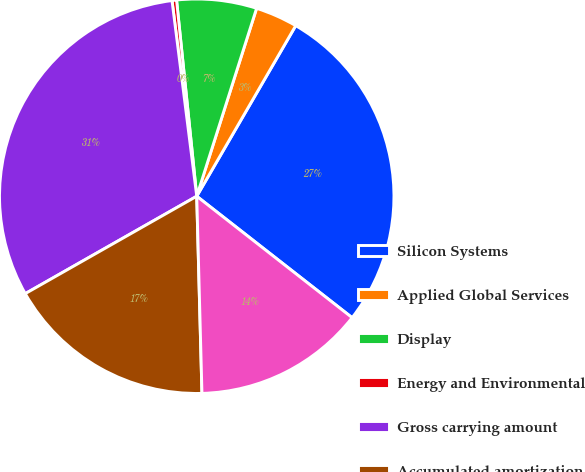<chart> <loc_0><loc_0><loc_500><loc_500><pie_chart><fcel>Silicon Systems<fcel>Applied Global Services<fcel>Display<fcel>Energy and Environmental<fcel>Gross carrying amount<fcel>Accumulated amortization<fcel>Carrying amount<nl><fcel>27.19%<fcel>3.46%<fcel>6.54%<fcel>0.37%<fcel>31.22%<fcel>17.2%<fcel>14.02%<nl></chart> 